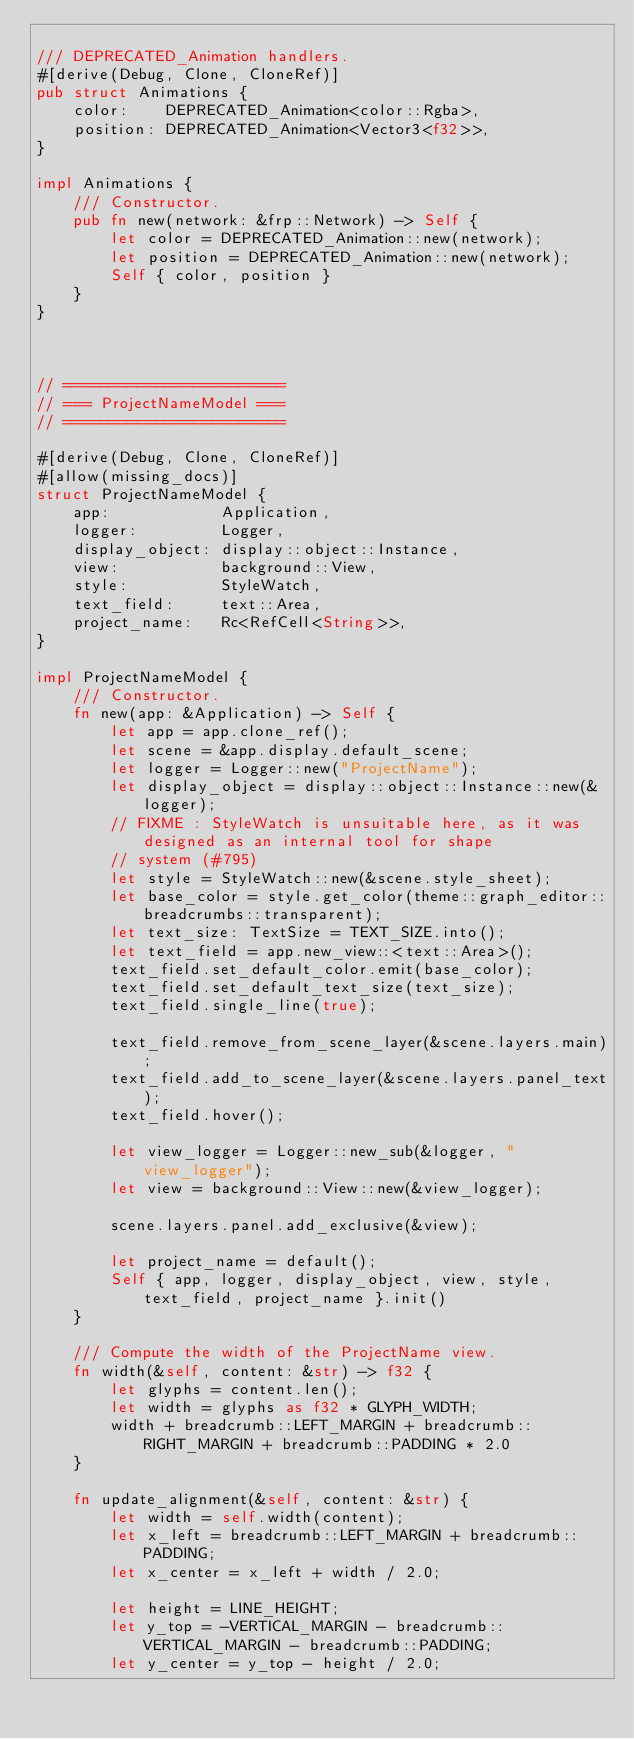Convert code to text. <code><loc_0><loc_0><loc_500><loc_500><_Rust_>
/// DEPRECATED_Animation handlers.
#[derive(Debug, Clone, CloneRef)]
pub struct Animations {
    color:    DEPRECATED_Animation<color::Rgba>,
    position: DEPRECATED_Animation<Vector3<f32>>,
}

impl Animations {
    /// Constructor.
    pub fn new(network: &frp::Network) -> Self {
        let color = DEPRECATED_Animation::new(network);
        let position = DEPRECATED_Animation::new(network);
        Self { color, position }
    }
}



// ========================
// === ProjectNameModel ===
// ========================

#[derive(Debug, Clone, CloneRef)]
#[allow(missing_docs)]
struct ProjectNameModel {
    app:            Application,
    logger:         Logger,
    display_object: display::object::Instance,
    view:           background::View,
    style:          StyleWatch,
    text_field:     text::Area,
    project_name:   Rc<RefCell<String>>,
}

impl ProjectNameModel {
    /// Constructor.
    fn new(app: &Application) -> Self {
        let app = app.clone_ref();
        let scene = &app.display.default_scene;
        let logger = Logger::new("ProjectName");
        let display_object = display::object::Instance::new(&logger);
        // FIXME : StyleWatch is unsuitable here, as it was designed as an internal tool for shape
        // system (#795)
        let style = StyleWatch::new(&scene.style_sheet);
        let base_color = style.get_color(theme::graph_editor::breadcrumbs::transparent);
        let text_size: TextSize = TEXT_SIZE.into();
        let text_field = app.new_view::<text::Area>();
        text_field.set_default_color.emit(base_color);
        text_field.set_default_text_size(text_size);
        text_field.single_line(true);

        text_field.remove_from_scene_layer(&scene.layers.main);
        text_field.add_to_scene_layer(&scene.layers.panel_text);
        text_field.hover();

        let view_logger = Logger::new_sub(&logger, "view_logger");
        let view = background::View::new(&view_logger);

        scene.layers.panel.add_exclusive(&view);

        let project_name = default();
        Self { app, logger, display_object, view, style, text_field, project_name }.init()
    }

    /// Compute the width of the ProjectName view.
    fn width(&self, content: &str) -> f32 {
        let glyphs = content.len();
        let width = glyphs as f32 * GLYPH_WIDTH;
        width + breadcrumb::LEFT_MARGIN + breadcrumb::RIGHT_MARGIN + breadcrumb::PADDING * 2.0
    }

    fn update_alignment(&self, content: &str) {
        let width = self.width(content);
        let x_left = breadcrumb::LEFT_MARGIN + breadcrumb::PADDING;
        let x_center = x_left + width / 2.0;

        let height = LINE_HEIGHT;
        let y_top = -VERTICAL_MARGIN - breadcrumb::VERTICAL_MARGIN - breadcrumb::PADDING;
        let y_center = y_top - height / 2.0;
</code> 